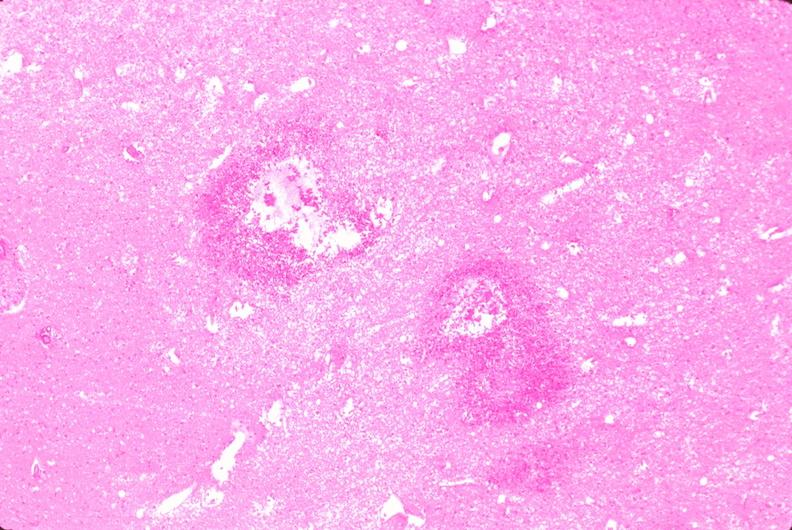what is present?
Answer the question using a single word or phrase. Nervous 